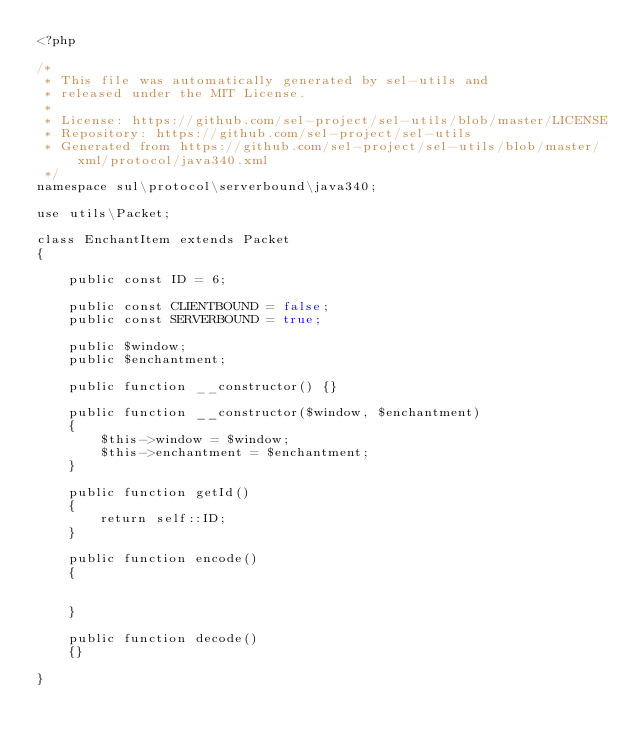Convert code to text. <code><loc_0><loc_0><loc_500><loc_500><_PHP_><?php

/*
 * This file was automatically generated by sel-utils and
 * released under the MIT License.
 * 
 * License: https://github.com/sel-project/sel-utils/blob/master/LICENSE
 * Repository: https://github.com/sel-project/sel-utils
 * Generated from https://github.com/sel-project/sel-utils/blob/master/xml/protocol/java340.xml
 */
namespace sul\protocol\serverbound\java340;

use utils\Packet;

class EnchantItem extends Packet
{

    public const ID = 6;

    public const CLIENTBOUND = false;
    public const SERVERBOUND = true;

    public $window;
    public $enchantment;

    public function __constructor() {}

    public function __constructor($window, $enchantment)
    {
        $this->window = $window;
        $this->enchantment = $enchantment;
    }

    public function getId()
    {
        return self::ID;
    }

    public function encode()
    {


    }

    public function decode()
    {}

}

</code> 